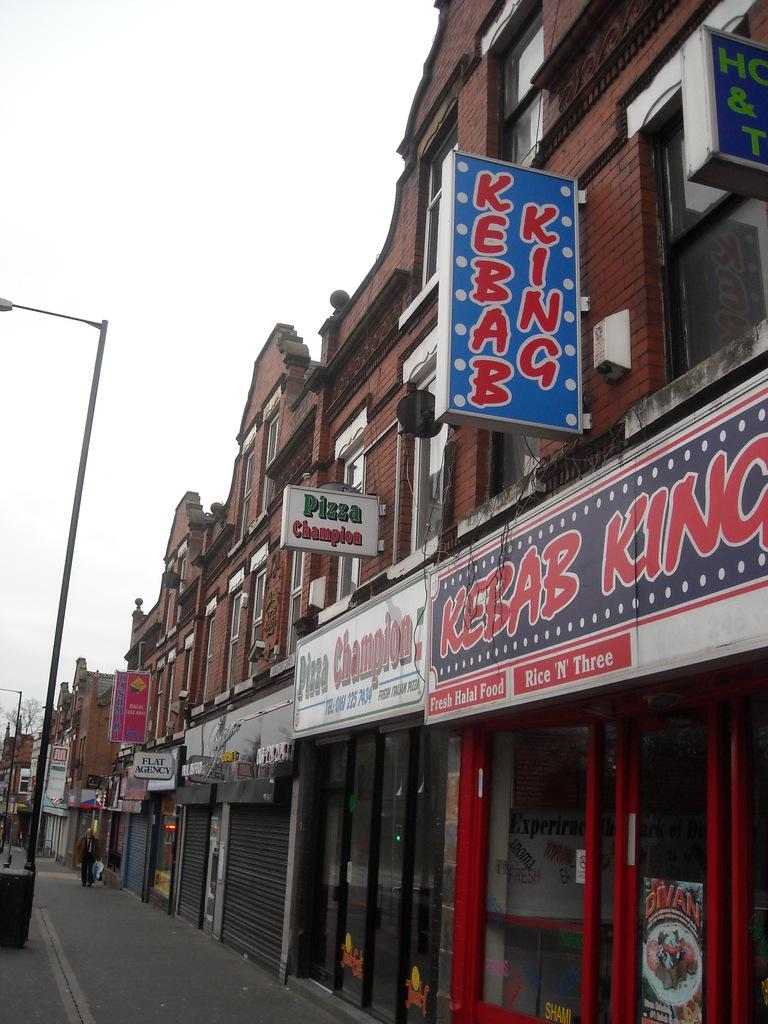What can be seen on the right side of the image? There are many buildings and hoardings on the right side of the image. What is present on the left side of the image? There are street lights on the left side of the image. What is the nature of the path in the image? This is a path. Can you describe the person in the image? There is a person in the image. What is the condition of the sky in the image? The sky is clear in the image. What type of leather is being used as bait in the image? There is no leather or bait present in the image. What hope does the person in the image have for the future? The image does not provide any information about the person's hopes or future plans. 